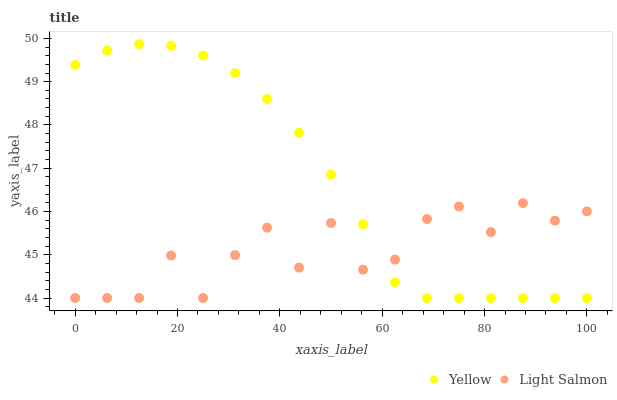Does Light Salmon have the minimum area under the curve?
Answer yes or no. Yes. Does Yellow have the maximum area under the curve?
Answer yes or no. Yes. Does Yellow have the minimum area under the curve?
Answer yes or no. No. Is Yellow the smoothest?
Answer yes or no. Yes. Is Light Salmon the roughest?
Answer yes or no. Yes. Is Yellow the roughest?
Answer yes or no. No. Does Light Salmon have the lowest value?
Answer yes or no. Yes. Does Yellow have the highest value?
Answer yes or no. Yes. Does Yellow intersect Light Salmon?
Answer yes or no. Yes. Is Yellow less than Light Salmon?
Answer yes or no. No. Is Yellow greater than Light Salmon?
Answer yes or no. No. 